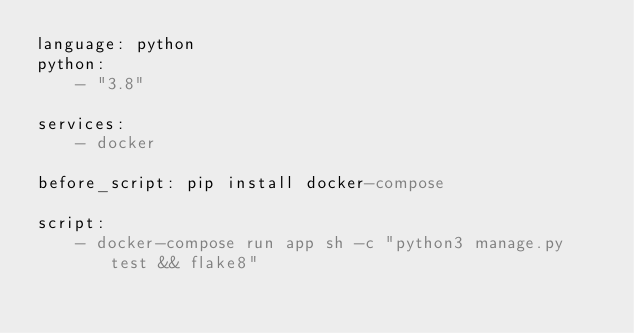<code> <loc_0><loc_0><loc_500><loc_500><_YAML_>language: python
python:
    - "3.8"

services:
    - docker

before_script: pip install docker-compose

script:
    - docker-compose run app sh -c "python3 manage.py test && flake8"
</code> 